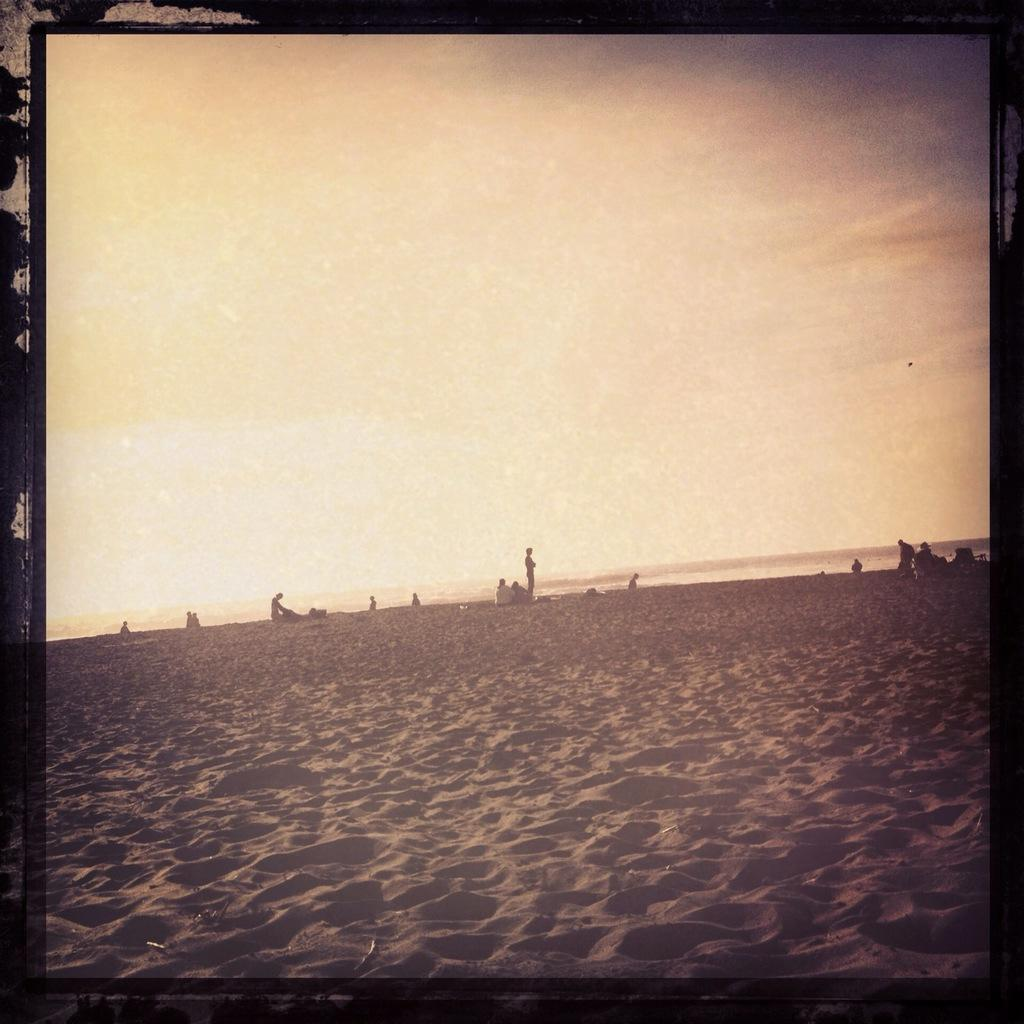What is the main subject of the image? The main subject of the image is the persons in the center of the image. What can be seen at the bottom of the image? Soil is present at the bottom of the image. What is visible at the top of the image? The sky is visible at the top of the image. How many silver bikes are being ridden by the judge in the image? There is no judge or bikes present in the image, and therefore no such activity can be observed. 